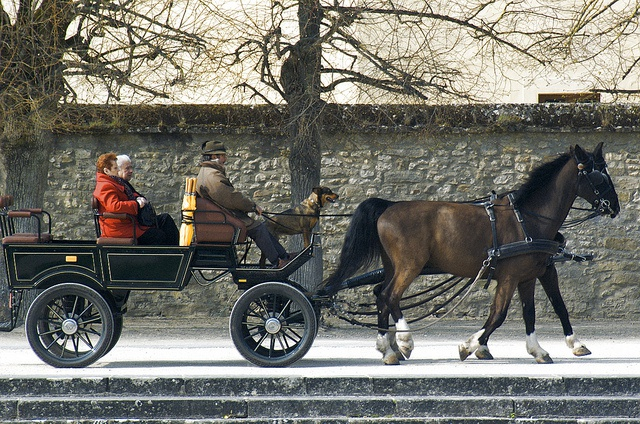Describe the objects in this image and their specific colors. I can see horse in olive, black, and gray tones, people in olive, black, gray, and darkgray tones, people in olive, maroon, black, brown, and red tones, dog in olive, black, and gray tones, and umbrella in olive, ivory, khaki, gold, and orange tones in this image. 